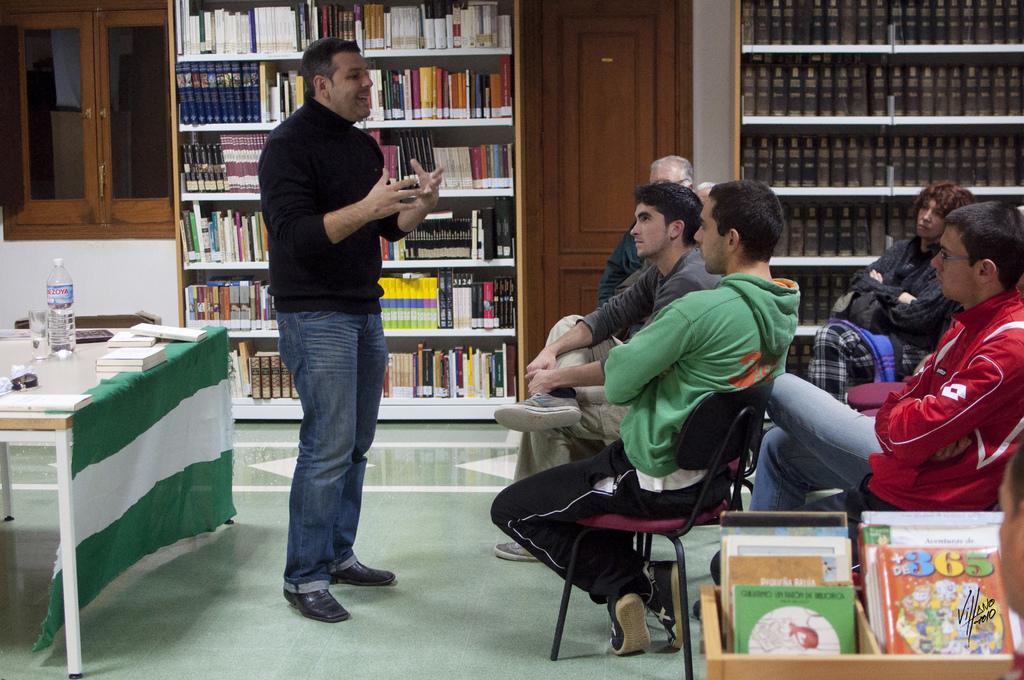Could you give a brief overview of what you see in this image? In this image there are group of persons sitting and a person standing at the middle of the image at the left side of the image there are books water bottles on the table and at the background of the image there are books,door,window. 